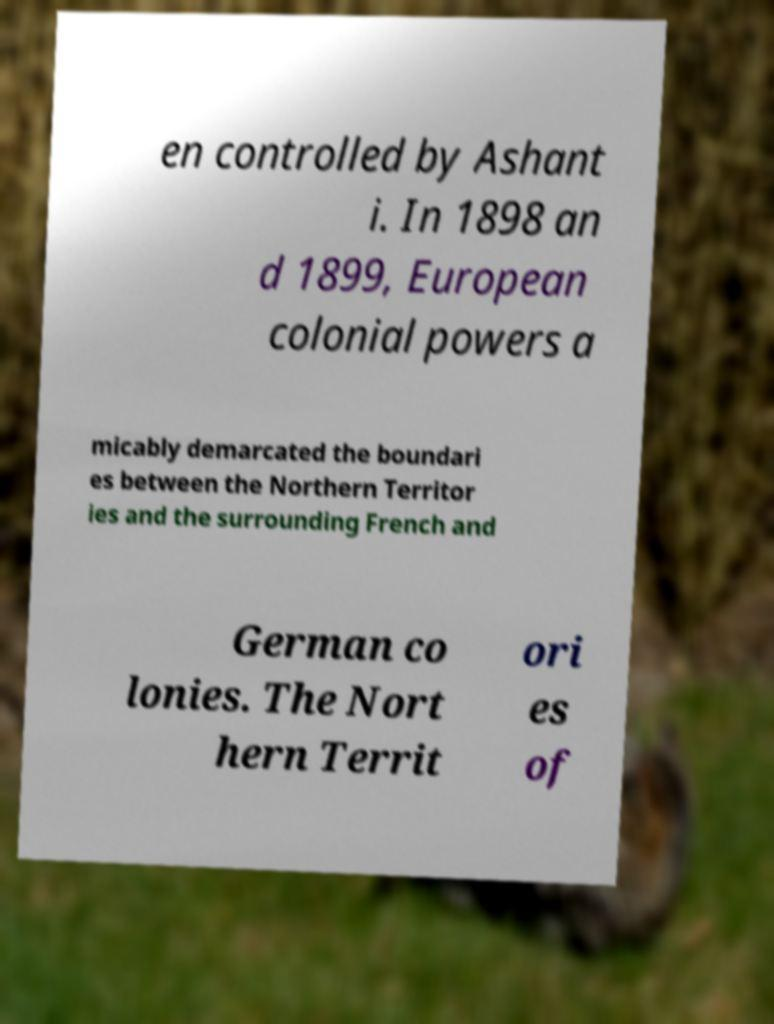Can you read and provide the text displayed in the image?This photo seems to have some interesting text. Can you extract and type it out for me? en controlled by Ashant i. In 1898 an d 1899, European colonial powers a micably demarcated the boundari es between the Northern Territor ies and the surrounding French and German co lonies. The Nort hern Territ ori es of 